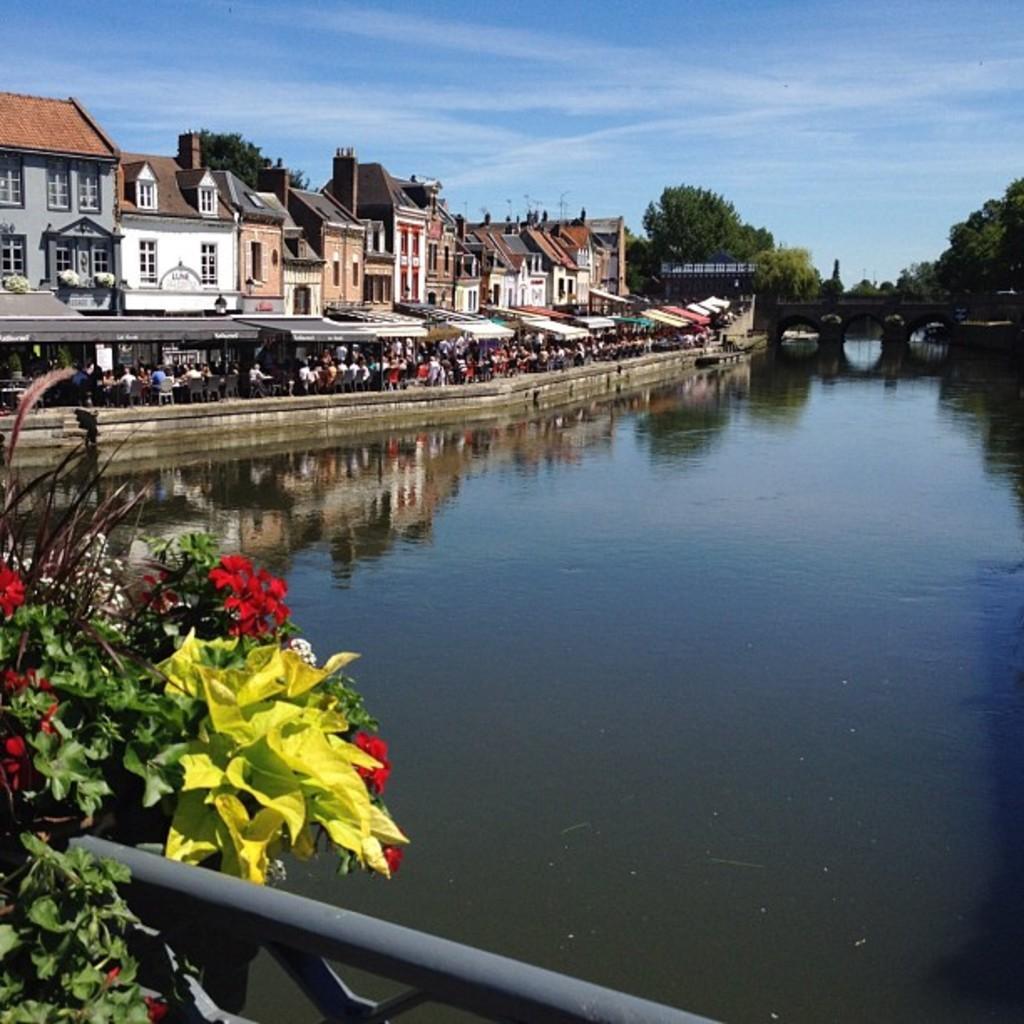Describe this image in one or two sentences. In the image there is lake on left side with buildings on right side and people walking on the road and above its sky. 